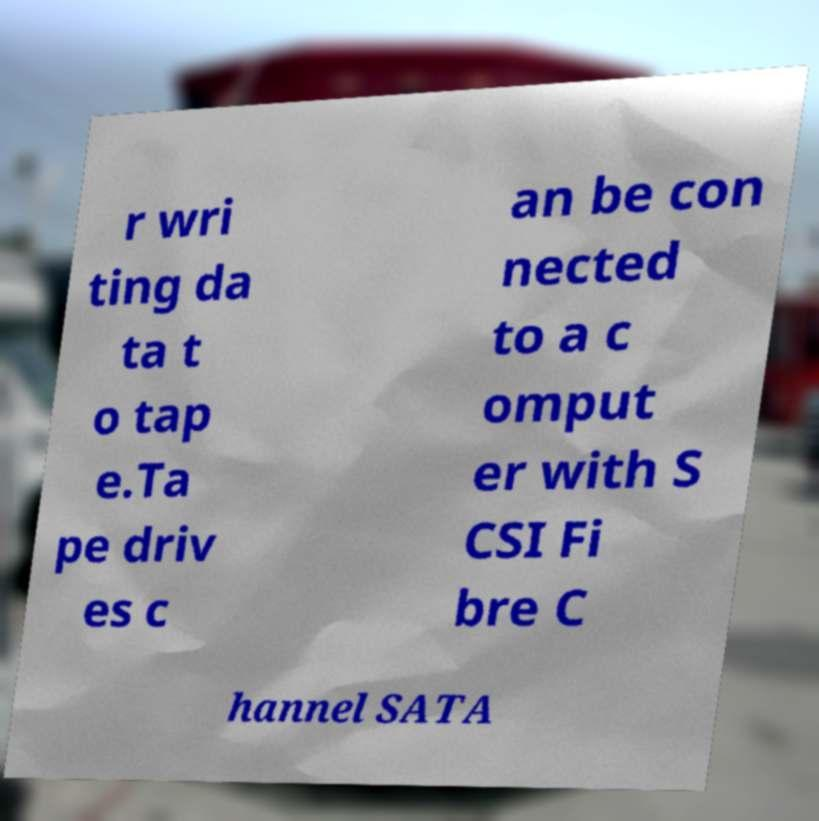For documentation purposes, I need the text within this image transcribed. Could you provide that? r wri ting da ta t o tap e.Ta pe driv es c an be con nected to a c omput er with S CSI Fi bre C hannel SATA 